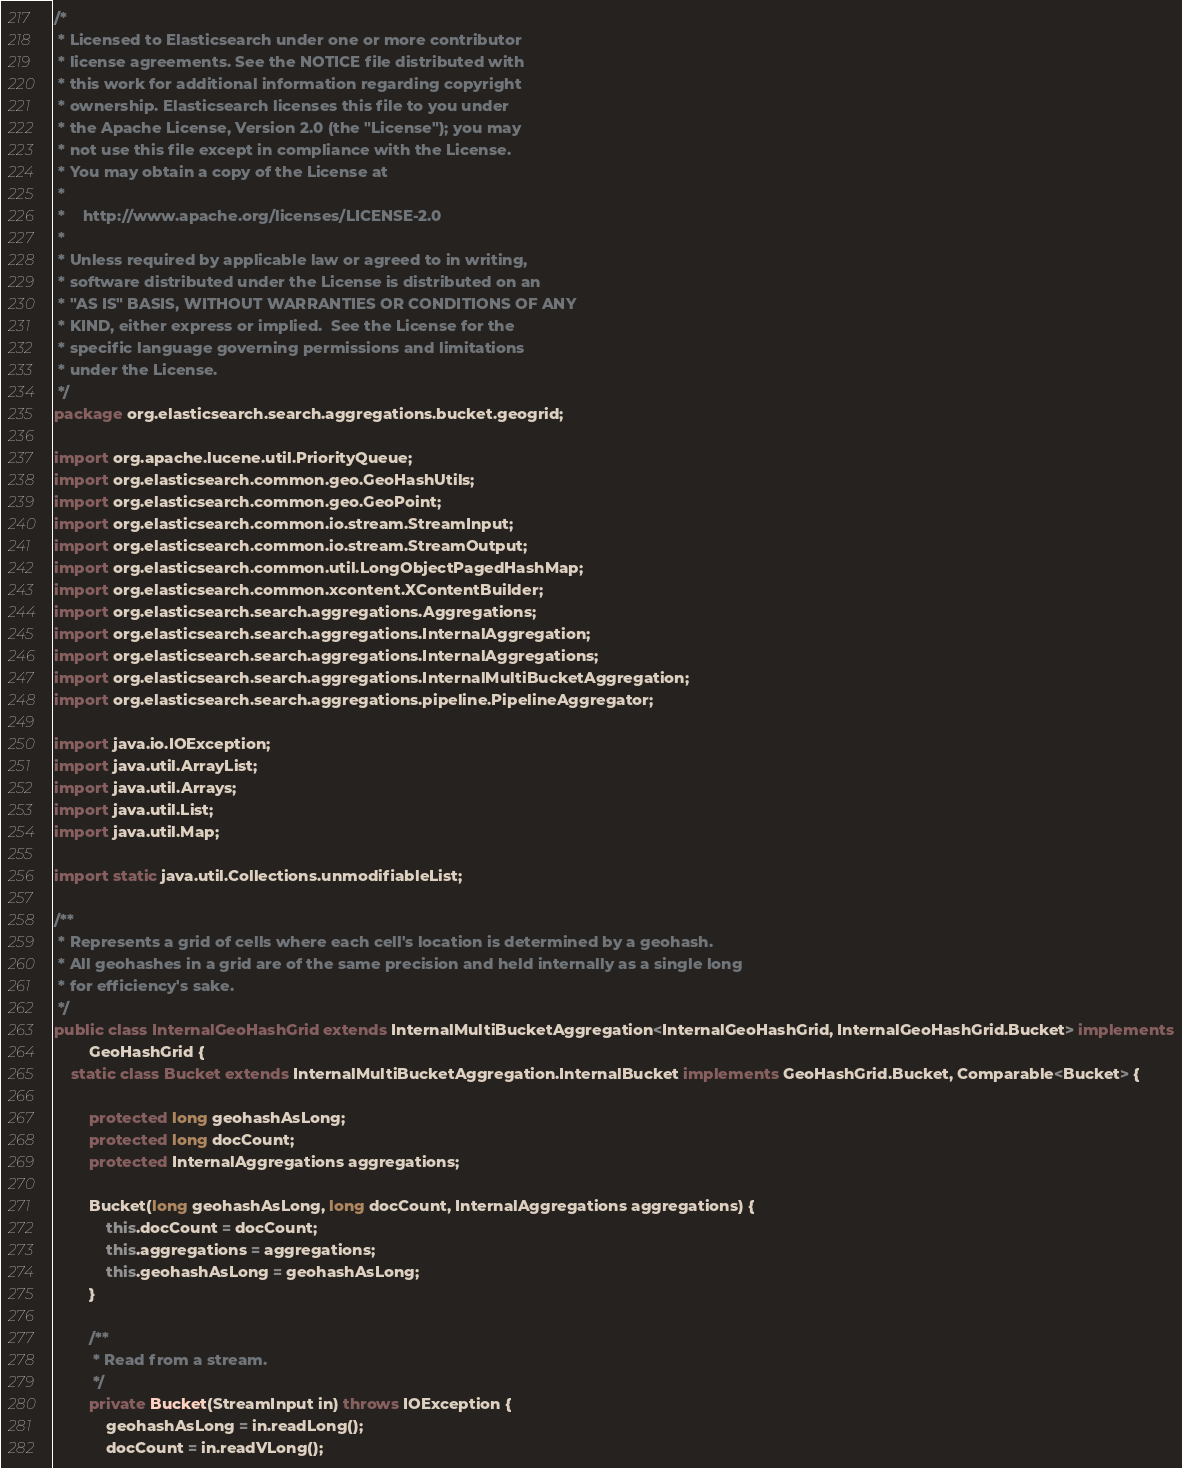Convert code to text. <code><loc_0><loc_0><loc_500><loc_500><_Java_>/*
 * Licensed to Elasticsearch under one or more contributor
 * license agreements. See the NOTICE file distributed with
 * this work for additional information regarding copyright
 * ownership. Elasticsearch licenses this file to you under
 * the Apache License, Version 2.0 (the "License"); you may
 * not use this file except in compliance with the License.
 * You may obtain a copy of the License at
 *
 *    http://www.apache.org/licenses/LICENSE-2.0
 *
 * Unless required by applicable law or agreed to in writing,
 * software distributed under the License is distributed on an
 * "AS IS" BASIS, WITHOUT WARRANTIES OR CONDITIONS OF ANY
 * KIND, either express or implied.  See the License for the
 * specific language governing permissions and limitations
 * under the License.
 */
package org.elasticsearch.search.aggregations.bucket.geogrid;

import org.apache.lucene.util.PriorityQueue;
import org.elasticsearch.common.geo.GeoHashUtils;
import org.elasticsearch.common.geo.GeoPoint;
import org.elasticsearch.common.io.stream.StreamInput;
import org.elasticsearch.common.io.stream.StreamOutput;
import org.elasticsearch.common.util.LongObjectPagedHashMap;
import org.elasticsearch.common.xcontent.XContentBuilder;
import org.elasticsearch.search.aggregations.Aggregations;
import org.elasticsearch.search.aggregations.InternalAggregation;
import org.elasticsearch.search.aggregations.InternalAggregations;
import org.elasticsearch.search.aggregations.InternalMultiBucketAggregation;
import org.elasticsearch.search.aggregations.pipeline.PipelineAggregator;

import java.io.IOException;
import java.util.ArrayList;
import java.util.Arrays;
import java.util.List;
import java.util.Map;

import static java.util.Collections.unmodifiableList;

/**
 * Represents a grid of cells where each cell's location is determined by a geohash.
 * All geohashes in a grid are of the same precision and held internally as a single long
 * for efficiency's sake.
 */
public class InternalGeoHashGrid extends InternalMultiBucketAggregation<InternalGeoHashGrid, InternalGeoHashGrid.Bucket> implements
        GeoHashGrid {
    static class Bucket extends InternalMultiBucketAggregation.InternalBucket implements GeoHashGrid.Bucket, Comparable<Bucket> {

        protected long geohashAsLong;
        protected long docCount;
        protected InternalAggregations aggregations;

        Bucket(long geohashAsLong, long docCount, InternalAggregations aggregations) {
            this.docCount = docCount;
            this.aggregations = aggregations;
            this.geohashAsLong = geohashAsLong;
        }

        /**
         * Read from a stream.
         */
        private Bucket(StreamInput in) throws IOException {
            geohashAsLong = in.readLong();
            docCount = in.readVLong();</code> 